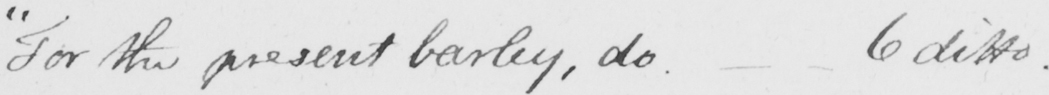Transcribe the text shown in this historical manuscript line. " For the present barley , do .  _   _  6 ditto . 